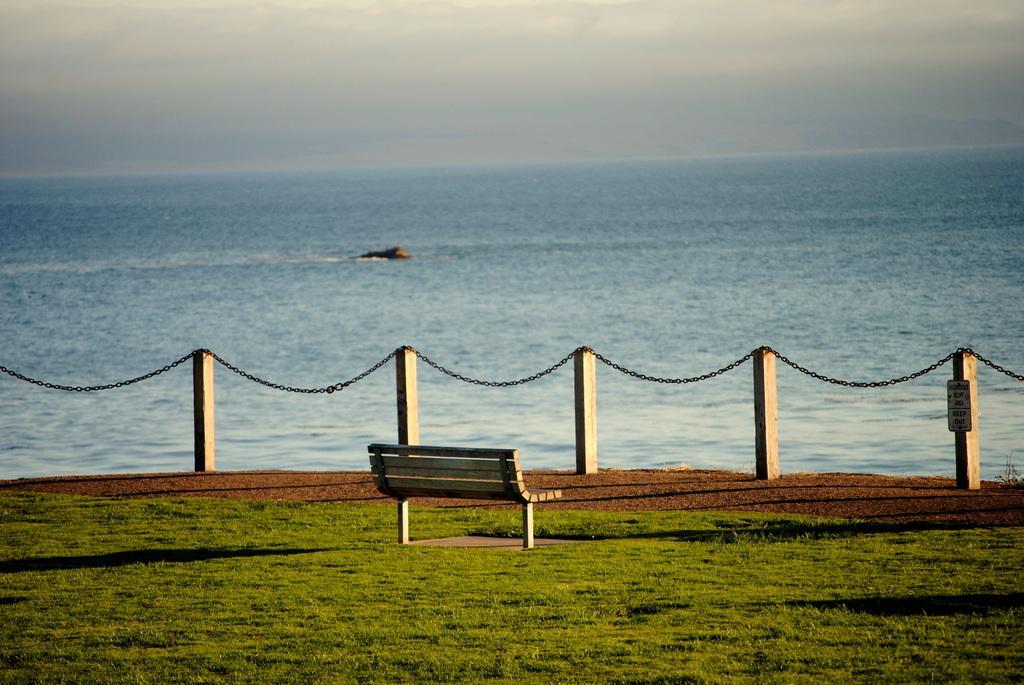Describe this image in one or two sentences. In this image we can see a wooden fence included with a chain and we can also see a sitting bench, grass, water and sky. 